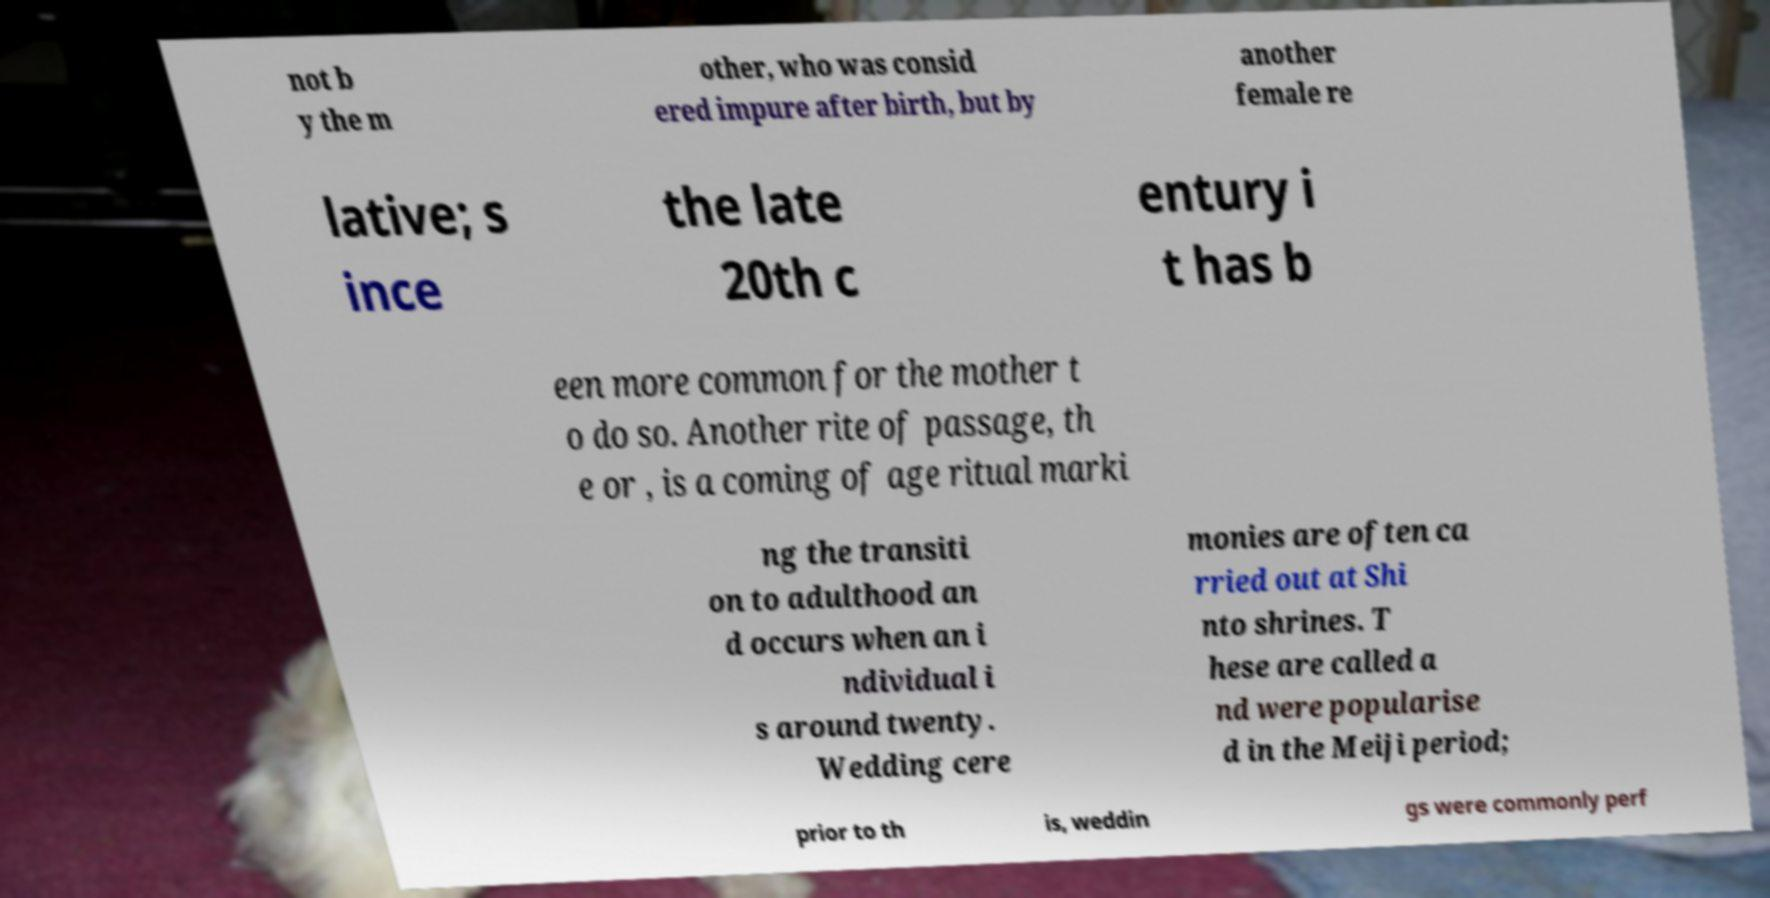I need the written content from this picture converted into text. Can you do that? not b y the m other, who was consid ered impure after birth, but by another female re lative; s ince the late 20th c entury i t has b een more common for the mother t o do so. Another rite of passage, th e or , is a coming of age ritual marki ng the transiti on to adulthood an d occurs when an i ndividual i s around twenty. Wedding cere monies are often ca rried out at Shi nto shrines. T hese are called a nd were popularise d in the Meiji period; prior to th is, weddin gs were commonly perf 